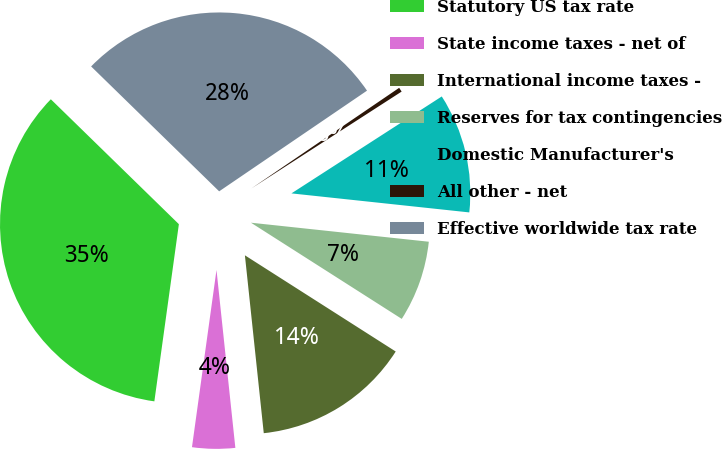<chart> <loc_0><loc_0><loc_500><loc_500><pie_chart><fcel>Statutory US tax rate<fcel>State income taxes - net of<fcel>International income taxes -<fcel>Reserves for tax contingencies<fcel>Domestic Manufacturer's<fcel>All other - net<fcel>Effective worldwide tax rate<nl><fcel>35.11%<fcel>3.87%<fcel>14.28%<fcel>7.34%<fcel>10.81%<fcel>0.4%<fcel>28.18%<nl></chart> 